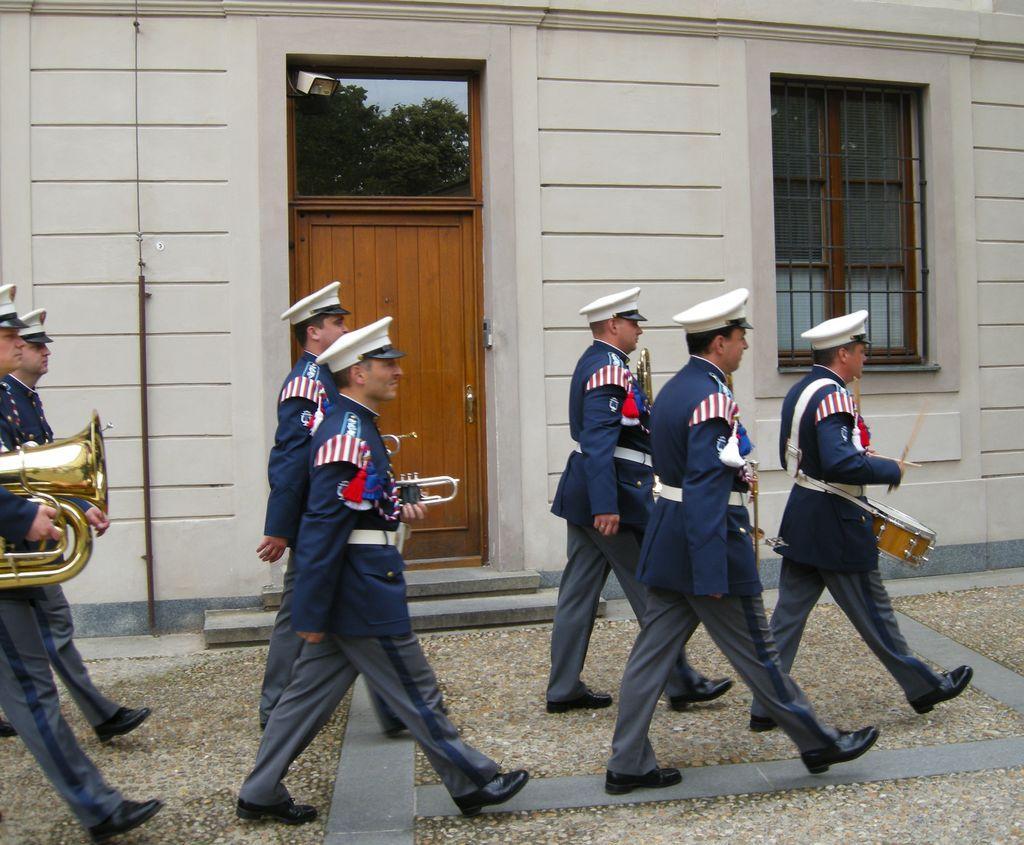Please provide a concise description of this image. This picture is clicked outside. In the center we can see the group of people wearing uniforms, holding the musical instruments and walking on the ground. In the background we can see the house and we can see the window, door and the wall of the house, we can see the reflections of the sky and the trees on the glass and we can see some other items. 